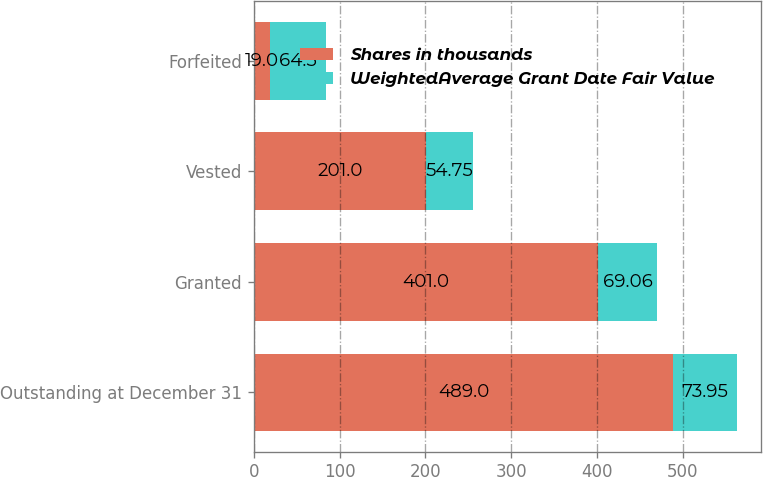Convert chart. <chart><loc_0><loc_0><loc_500><loc_500><stacked_bar_chart><ecel><fcel>Outstanding at December 31<fcel>Granted<fcel>Vested<fcel>Forfeited<nl><fcel>Shares in thousands<fcel>489<fcel>401<fcel>201<fcel>19<nl><fcel>WeightedAverage Grant Date Fair Value<fcel>73.95<fcel>69.06<fcel>54.75<fcel>64.5<nl></chart> 